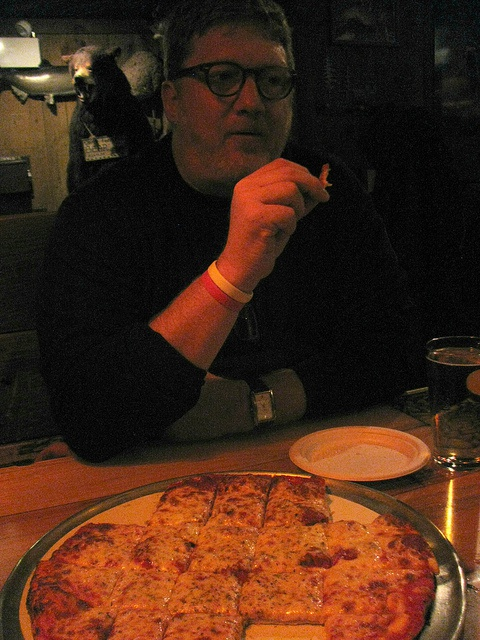Describe the objects in this image and their specific colors. I can see people in black, maroon, brown, and red tones, pizza in black, red, brown, and maroon tones, dining table in black, maroon, and brown tones, and cup in black, maroon, and brown tones in this image. 